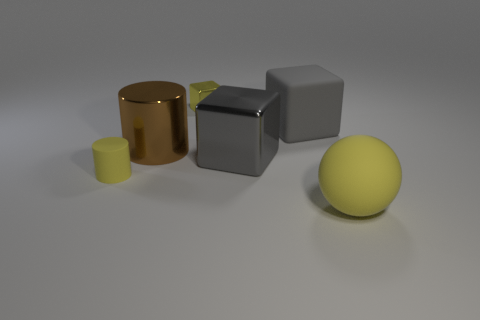Add 1 small yellow metal cubes. How many objects exist? 7 Subtract all cylinders. How many objects are left? 4 Add 4 tiny metallic cubes. How many tiny metallic cubes exist? 5 Subtract 0 red spheres. How many objects are left? 6 Subtract all big brown metal spheres. Subtract all small yellow matte things. How many objects are left? 5 Add 3 brown cylinders. How many brown cylinders are left? 4 